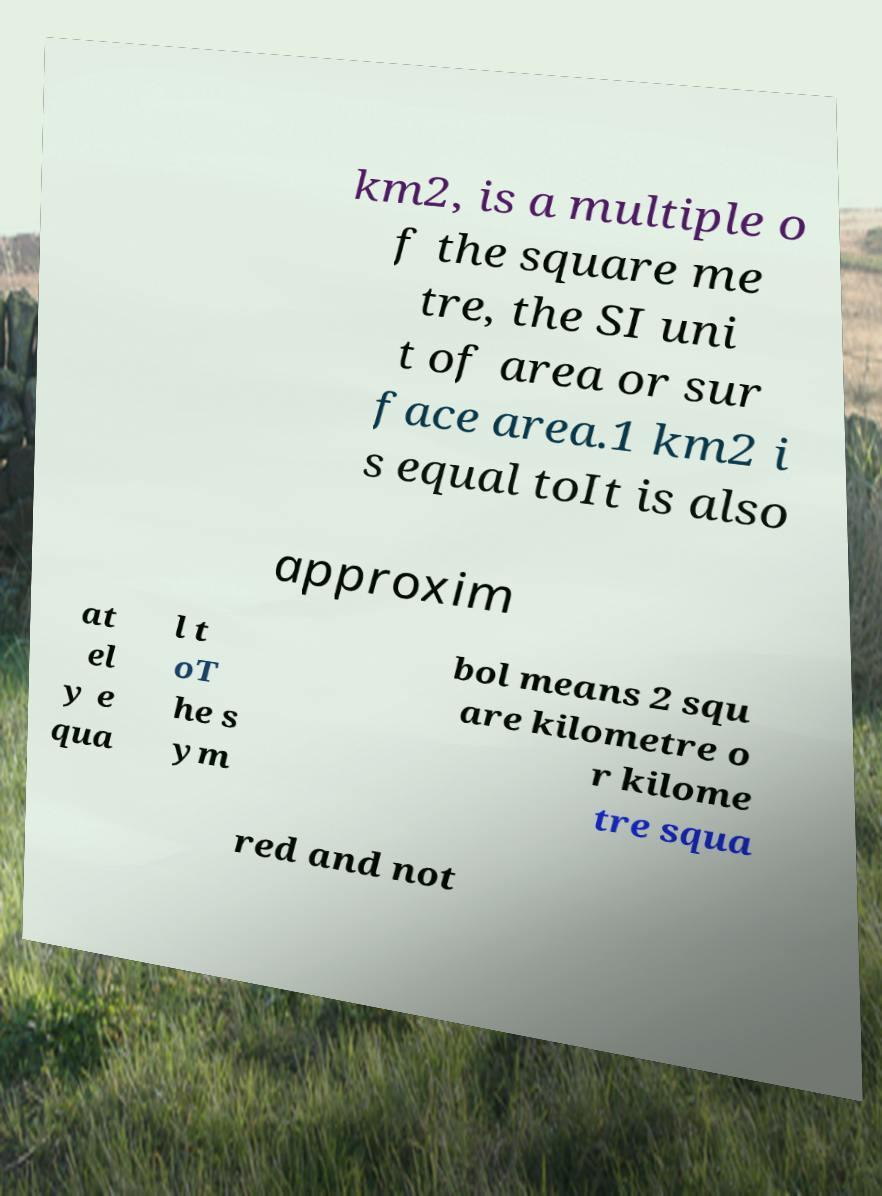Can you accurately transcribe the text from the provided image for me? km2, is a multiple o f the square me tre, the SI uni t of area or sur face area.1 km2 i s equal toIt is also approxim at el y e qua l t oT he s ym bol means 2 squ are kilometre o r kilome tre squa red and not 